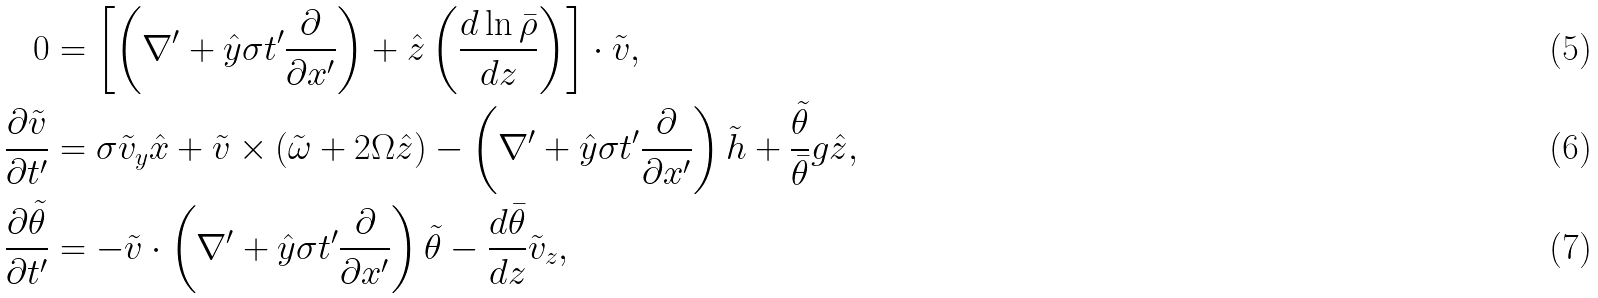Convert formula to latex. <formula><loc_0><loc_0><loc_500><loc_500>0 & = \left [ \left ( \nabla ^ { \prime } + \hat { y } \sigma t ^ { \prime } \frac { \partial } { \partial x ^ { \prime } } \right ) + \hat { z } \left ( \frac { d \ln \bar { \rho } } { d z } \right ) \right ] \cdot \tilde { v } , \\ \frac { \partial \tilde { v } } { \partial t ^ { \prime } } & = \sigma \tilde { v } _ { y } \hat { x } + \tilde { v } \times ( \tilde { \omega } + 2 \Omega \hat { z } ) - \left ( \nabla ^ { \prime } + \hat { y } \sigma t ^ { \prime } \frac { \partial } { \partial x ^ { \prime } } \right ) \tilde { h } + \frac { \tilde { \theta } } { \bar { \theta } } g \hat { z } , \\ \frac { \partial \tilde { \theta } } { \partial t ^ { \prime } } & = - \tilde { v } \cdot \left ( \nabla ^ { \prime } + \hat { y } \sigma t ^ { \prime } \frac { \partial } { \partial x ^ { \prime } } \right ) \tilde { \theta } - \frac { d \bar { \theta } } { d z } \tilde { v } _ { z } ,</formula> 